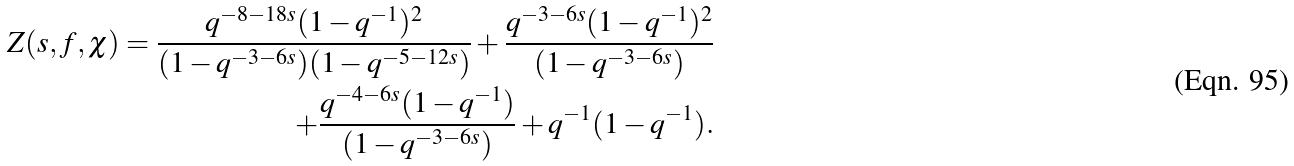<formula> <loc_0><loc_0><loc_500><loc_500>Z ( s , f , \chi ) = \frac { q ^ { - 8 - 1 8 s } ( 1 - q ^ { - 1 } ) ^ { 2 } } { ( 1 - q ^ { - 3 - 6 s } ) ( 1 - q ^ { - 5 - 1 2 s } ) } + \frac { q ^ { - 3 - 6 s } ( 1 - q ^ { - 1 } ) ^ { 2 } } { ( 1 - q ^ { - 3 - 6 s } ) } \\ + \frac { q ^ { - 4 - 6 s } ( 1 - q ^ { - 1 } ) } { ( 1 - q ^ { - 3 - 6 s } ) } + q ^ { - 1 } ( 1 - q ^ { - 1 } ) .</formula> 